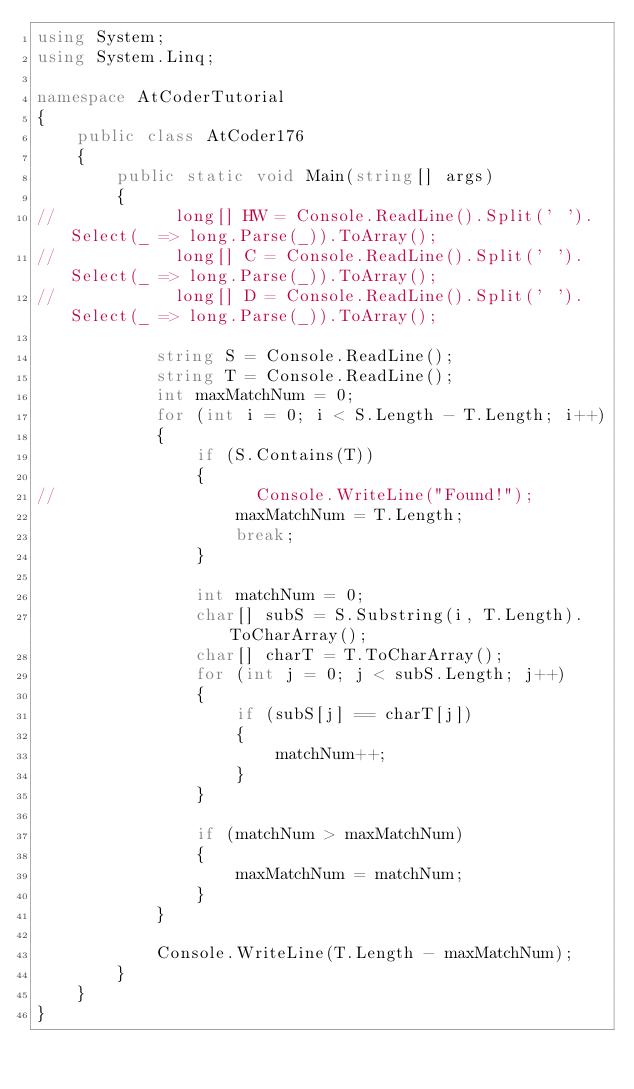Convert code to text. <code><loc_0><loc_0><loc_500><loc_500><_C#_>using System;
using System.Linq;

namespace AtCoderTutorial
{
    public class AtCoder176
    {
        public static void Main(string[] args)
        {
//            long[] HW = Console.ReadLine().Split(' ').Select(_ => long.Parse(_)).ToArray();
//            long[] C = Console.ReadLine().Split(' ').Select(_ => long.Parse(_)).ToArray();
//            long[] D = Console.ReadLine().Split(' ').Select(_ => long.Parse(_)).ToArray();

            string S = Console.ReadLine();
            string T = Console.ReadLine();
            int maxMatchNum = 0;
            for (int i = 0; i < S.Length - T.Length; i++)
            {
                if (S.Contains(T))
                {
//                    Console.WriteLine("Found!");
                    maxMatchNum = T.Length;
                    break;
                }

                int matchNum = 0;
                char[] subS = S.Substring(i, T.Length).ToCharArray();
                char[] charT = T.ToCharArray();
                for (int j = 0; j < subS.Length; j++)
                {
                    if (subS[j] == charT[j])
                    {
                        matchNum++;
                    }
                }

                if (matchNum > maxMatchNum)
                {
                    maxMatchNum = matchNum;
                }
            }

            Console.WriteLine(T.Length - maxMatchNum);
        }
    }
}</code> 